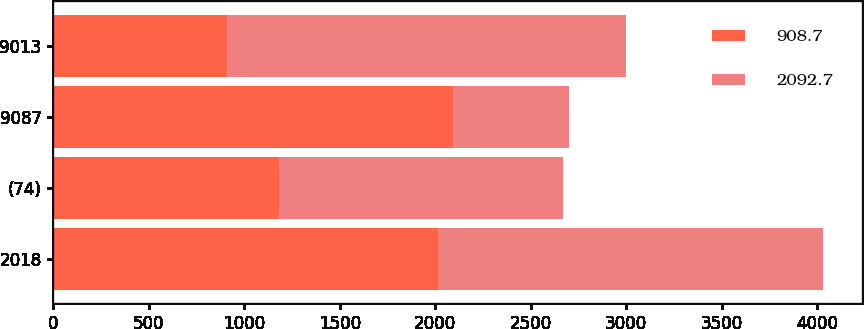Convert chart. <chart><loc_0><loc_0><loc_500><loc_500><stacked_bar_chart><ecel><fcel>2018<fcel>(74)<fcel>9087<fcel>9013<nl><fcel>908.7<fcel>2017<fcel>1184<fcel>2092.7<fcel>908.7<nl><fcel>2092.7<fcel>2016<fcel>1484.9<fcel>607.8<fcel>2092.7<nl></chart> 